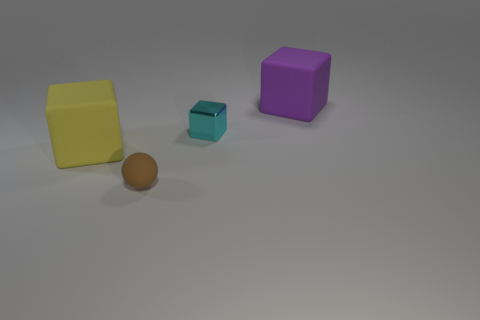Compared to the other objects, how would you describe the material of the yellow block? The yellow block appears to have a matte finish, which diffuses light and gives it a non-reflective, smooth texture. This contrasts with the shiny surface of the small turquoise block and the slightly reflective finish on the purple cube and the sphere. 